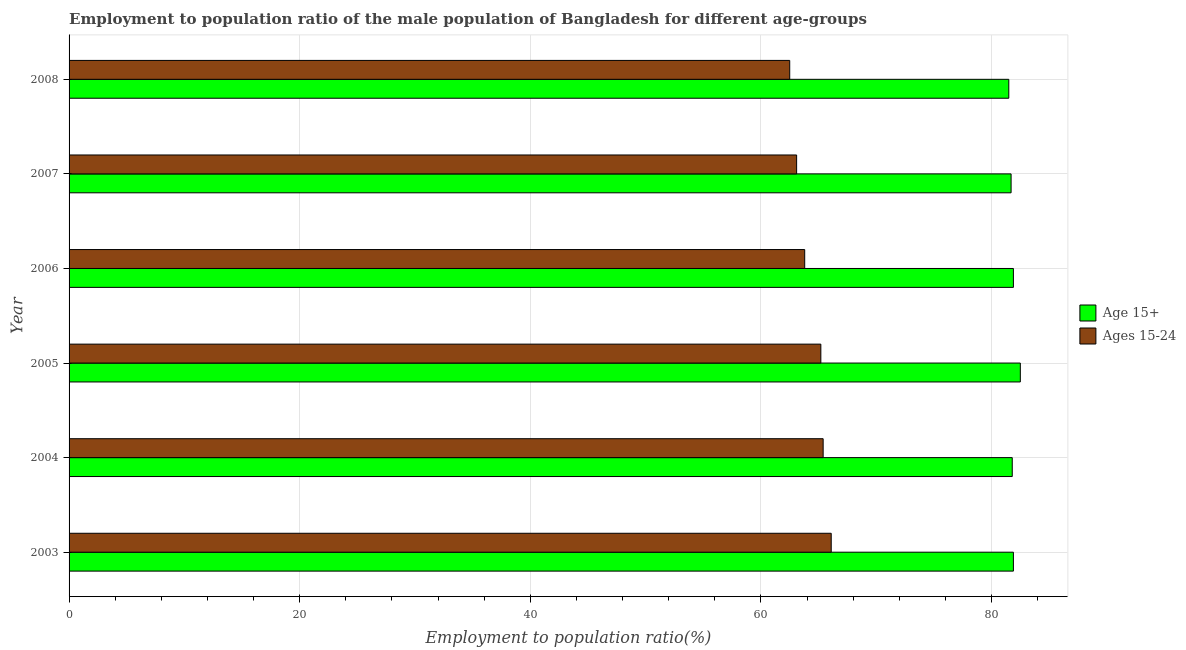Are the number of bars per tick equal to the number of legend labels?
Ensure brevity in your answer.  Yes. How many bars are there on the 4th tick from the bottom?
Offer a terse response. 2. What is the employment to population ratio(age 15+) in 2003?
Ensure brevity in your answer.  81.9. Across all years, what is the maximum employment to population ratio(age 15+)?
Your answer should be compact. 82.5. Across all years, what is the minimum employment to population ratio(age 15+)?
Provide a succinct answer. 81.5. In which year was the employment to population ratio(age 15+) maximum?
Make the answer very short. 2005. What is the total employment to population ratio(age 15+) in the graph?
Your response must be concise. 491.3. What is the difference between the employment to population ratio(age 15+) in 2006 and the employment to population ratio(age 15-24) in 2007?
Provide a succinct answer. 18.8. What is the average employment to population ratio(age 15-24) per year?
Keep it short and to the point. 64.35. In how many years, is the employment to population ratio(age 15+) greater than 8 %?
Your answer should be compact. 6. What is the ratio of the employment to population ratio(age 15+) in 2005 to that in 2006?
Keep it short and to the point. 1.01. What does the 1st bar from the top in 2007 represents?
Keep it short and to the point. Ages 15-24. What does the 2nd bar from the bottom in 2004 represents?
Ensure brevity in your answer.  Ages 15-24. How many bars are there?
Provide a short and direct response. 12. What is the difference between two consecutive major ticks on the X-axis?
Keep it short and to the point. 20. Does the graph contain any zero values?
Provide a short and direct response. No. Does the graph contain grids?
Provide a short and direct response. Yes. How many legend labels are there?
Your response must be concise. 2. How are the legend labels stacked?
Keep it short and to the point. Vertical. What is the title of the graph?
Your answer should be compact. Employment to population ratio of the male population of Bangladesh for different age-groups. Does "Female labourers" appear as one of the legend labels in the graph?
Offer a terse response. No. What is the label or title of the Y-axis?
Make the answer very short. Year. What is the Employment to population ratio(%) of Age 15+ in 2003?
Your response must be concise. 81.9. What is the Employment to population ratio(%) of Ages 15-24 in 2003?
Ensure brevity in your answer.  66.1. What is the Employment to population ratio(%) in Age 15+ in 2004?
Your answer should be very brief. 81.8. What is the Employment to population ratio(%) of Ages 15-24 in 2004?
Provide a succinct answer. 65.4. What is the Employment to population ratio(%) in Age 15+ in 2005?
Offer a very short reply. 82.5. What is the Employment to population ratio(%) of Ages 15-24 in 2005?
Offer a terse response. 65.2. What is the Employment to population ratio(%) of Age 15+ in 2006?
Offer a terse response. 81.9. What is the Employment to population ratio(%) in Ages 15-24 in 2006?
Your answer should be compact. 63.8. What is the Employment to population ratio(%) in Age 15+ in 2007?
Keep it short and to the point. 81.7. What is the Employment to population ratio(%) of Ages 15-24 in 2007?
Your response must be concise. 63.1. What is the Employment to population ratio(%) of Age 15+ in 2008?
Keep it short and to the point. 81.5. What is the Employment to population ratio(%) of Ages 15-24 in 2008?
Your answer should be compact. 62.5. Across all years, what is the maximum Employment to population ratio(%) in Age 15+?
Provide a short and direct response. 82.5. Across all years, what is the maximum Employment to population ratio(%) of Ages 15-24?
Provide a short and direct response. 66.1. Across all years, what is the minimum Employment to population ratio(%) of Age 15+?
Provide a succinct answer. 81.5. Across all years, what is the minimum Employment to population ratio(%) of Ages 15-24?
Provide a short and direct response. 62.5. What is the total Employment to population ratio(%) in Age 15+ in the graph?
Your response must be concise. 491.3. What is the total Employment to population ratio(%) in Ages 15-24 in the graph?
Give a very brief answer. 386.1. What is the difference between the Employment to population ratio(%) of Age 15+ in 2003 and that in 2004?
Offer a terse response. 0.1. What is the difference between the Employment to population ratio(%) of Age 15+ in 2003 and that in 2006?
Offer a very short reply. 0. What is the difference between the Employment to population ratio(%) of Ages 15-24 in 2003 and that in 2006?
Offer a terse response. 2.3. What is the difference between the Employment to population ratio(%) of Age 15+ in 2003 and that in 2007?
Keep it short and to the point. 0.2. What is the difference between the Employment to population ratio(%) in Ages 15-24 in 2003 and that in 2008?
Make the answer very short. 3.6. What is the difference between the Employment to population ratio(%) of Age 15+ in 2004 and that in 2005?
Offer a terse response. -0.7. What is the difference between the Employment to population ratio(%) of Age 15+ in 2004 and that in 2006?
Provide a succinct answer. -0.1. What is the difference between the Employment to population ratio(%) of Age 15+ in 2005 and that in 2006?
Provide a succinct answer. 0.6. What is the difference between the Employment to population ratio(%) in Ages 15-24 in 2005 and that in 2007?
Your answer should be compact. 2.1. What is the difference between the Employment to population ratio(%) of Age 15+ in 2005 and that in 2008?
Ensure brevity in your answer.  1. What is the difference between the Employment to population ratio(%) of Ages 15-24 in 2005 and that in 2008?
Your answer should be very brief. 2.7. What is the difference between the Employment to population ratio(%) of Age 15+ in 2006 and that in 2007?
Provide a short and direct response. 0.2. What is the difference between the Employment to population ratio(%) of Ages 15-24 in 2006 and that in 2008?
Provide a short and direct response. 1.3. What is the difference between the Employment to population ratio(%) of Age 15+ in 2007 and that in 2008?
Keep it short and to the point. 0.2. What is the difference between the Employment to population ratio(%) of Age 15+ in 2003 and the Employment to population ratio(%) of Ages 15-24 in 2004?
Your answer should be compact. 16.5. What is the difference between the Employment to population ratio(%) of Age 15+ in 2003 and the Employment to population ratio(%) of Ages 15-24 in 2005?
Keep it short and to the point. 16.7. What is the difference between the Employment to population ratio(%) of Age 15+ in 2003 and the Employment to population ratio(%) of Ages 15-24 in 2006?
Ensure brevity in your answer.  18.1. What is the difference between the Employment to population ratio(%) of Age 15+ in 2003 and the Employment to population ratio(%) of Ages 15-24 in 2007?
Offer a very short reply. 18.8. What is the difference between the Employment to population ratio(%) of Age 15+ in 2003 and the Employment to population ratio(%) of Ages 15-24 in 2008?
Provide a short and direct response. 19.4. What is the difference between the Employment to population ratio(%) in Age 15+ in 2004 and the Employment to population ratio(%) in Ages 15-24 in 2006?
Make the answer very short. 18. What is the difference between the Employment to population ratio(%) of Age 15+ in 2004 and the Employment to population ratio(%) of Ages 15-24 in 2007?
Your response must be concise. 18.7. What is the difference between the Employment to population ratio(%) in Age 15+ in 2004 and the Employment to population ratio(%) in Ages 15-24 in 2008?
Offer a very short reply. 19.3. What is the difference between the Employment to population ratio(%) in Age 15+ in 2005 and the Employment to population ratio(%) in Ages 15-24 in 2006?
Provide a short and direct response. 18.7. What is the difference between the Employment to population ratio(%) in Age 15+ in 2006 and the Employment to population ratio(%) in Ages 15-24 in 2008?
Offer a very short reply. 19.4. What is the difference between the Employment to population ratio(%) in Age 15+ in 2007 and the Employment to population ratio(%) in Ages 15-24 in 2008?
Your answer should be very brief. 19.2. What is the average Employment to population ratio(%) in Age 15+ per year?
Your answer should be compact. 81.88. What is the average Employment to population ratio(%) of Ages 15-24 per year?
Ensure brevity in your answer.  64.35. In the year 2005, what is the difference between the Employment to population ratio(%) of Age 15+ and Employment to population ratio(%) of Ages 15-24?
Provide a short and direct response. 17.3. What is the ratio of the Employment to population ratio(%) in Age 15+ in 2003 to that in 2004?
Your answer should be very brief. 1. What is the ratio of the Employment to population ratio(%) in Ages 15-24 in 2003 to that in 2004?
Your answer should be very brief. 1.01. What is the ratio of the Employment to population ratio(%) in Age 15+ in 2003 to that in 2005?
Offer a very short reply. 0.99. What is the ratio of the Employment to population ratio(%) of Ages 15-24 in 2003 to that in 2005?
Provide a succinct answer. 1.01. What is the ratio of the Employment to population ratio(%) in Ages 15-24 in 2003 to that in 2006?
Your answer should be very brief. 1.04. What is the ratio of the Employment to population ratio(%) of Age 15+ in 2003 to that in 2007?
Offer a very short reply. 1. What is the ratio of the Employment to population ratio(%) in Ages 15-24 in 2003 to that in 2007?
Your answer should be very brief. 1.05. What is the ratio of the Employment to population ratio(%) in Ages 15-24 in 2003 to that in 2008?
Keep it short and to the point. 1.06. What is the ratio of the Employment to population ratio(%) in Age 15+ in 2004 to that in 2005?
Give a very brief answer. 0.99. What is the ratio of the Employment to population ratio(%) in Ages 15-24 in 2004 to that in 2005?
Give a very brief answer. 1. What is the ratio of the Employment to population ratio(%) of Age 15+ in 2004 to that in 2006?
Provide a short and direct response. 1. What is the ratio of the Employment to population ratio(%) in Ages 15-24 in 2004 to that in 2006?
Offer a very short reply. 1.03. What is the ratio of the Employment to population ratio(%) of Ages 15-24 in 2004 to that in 2007?
Your answer should be very brief. 1.04. What is the ratio of the Employment to population ratio(%) in Ages 15-24 in 2004 to that in 2008?
Offer a terse response. 1.05. What is the ratio of the Employment to population ratio(%) in Age 15+ in 2005 to that in 2006?
Give a very brief answer. 1.01. What is the ratio of the Employment to population ratio(%) of Ages 15-24 in 2005 to that in 2006?
Offer a terse response. 1.02. What is the ratio of the Employment to population ratio(%) in Age 15+ in 2005 to that in 2007?
Your answer should be compact. 1.01. What is the ratio of the Employment to population ratio(%) of Ages 15-24 in 2005 to that in 2007?
Ensure brevity in your answer.  1.03. What is the ratio of the Employment to population ratio(%) in Age 15+ in 2005 to that in 2008?
Keep it short and to the point. 1.01. What is the ratio of the Employment to population ratio(%) of Ages 15-24 in 2005 to that in 2008?
Provide a short and direct response. 1.04. What is the ratio of the Employment to population ratio(%) in Ages 15-24 in 2006 to that in 2007?
Offer a terse response. 1.01. What is the ratio of the Employment to population ratio(%) in Ages 15-24 in 2006 to that in 2008?
Your answer should be compact. 1.02. What is the ratio of the Employment to population ratio(%) in Age 15+ in 2007 to that in 2008?
Provide a short and direct response. 1. What is the ratio of the Employment to population ratio(%) of Ages 15-24 in 2007 to that in 2008?
Provide a short and direct response. 1.01. What is the difference between the highest and the second highest Employment to population ratio(%) in Age 15+?
Offer a very short reply. 0.6. 